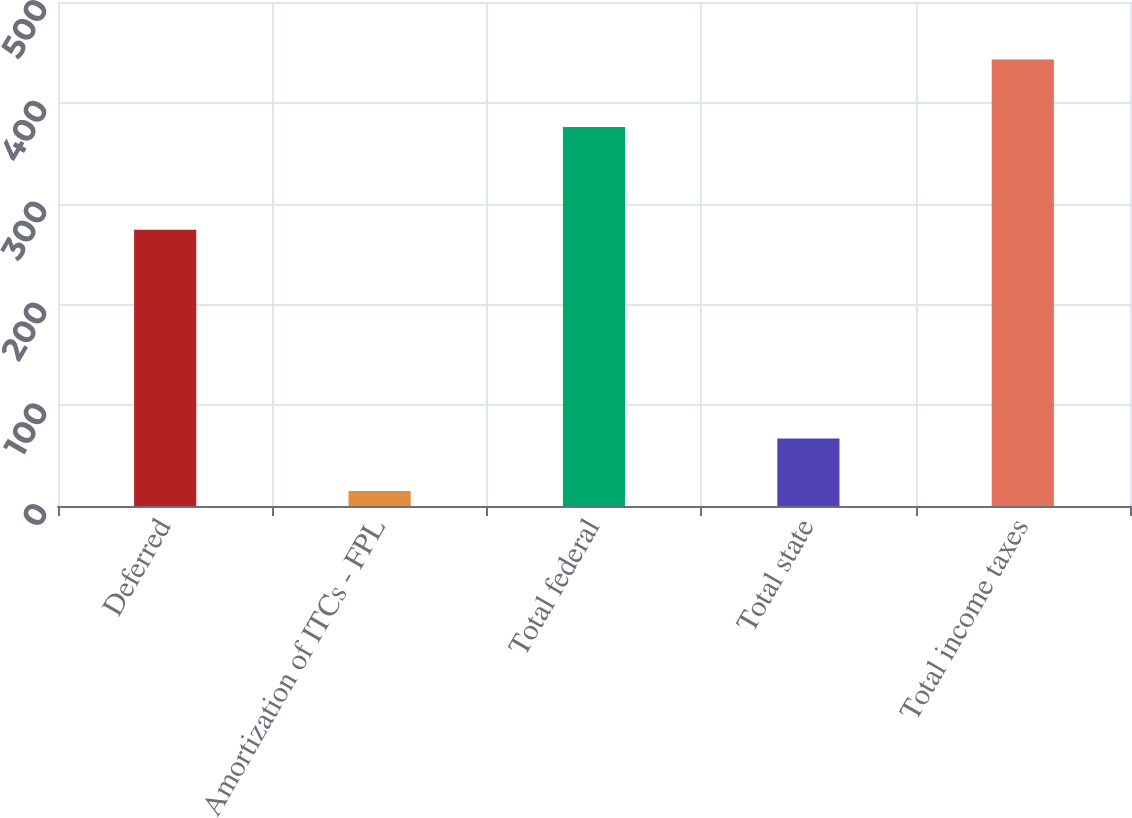Convert chart to OTSL. <chart><loc_0><loc_0><loc_500><loc_500><bar_chart><fcel>Deferred<fcel>Amortization of ITCs - FPL<fcel>Total federal<fcel>Total state<fcel>Total income taxes<nl><fcel>274<fcel>15<fcel>376<fcel>67<fcel>443<nl></chart> 